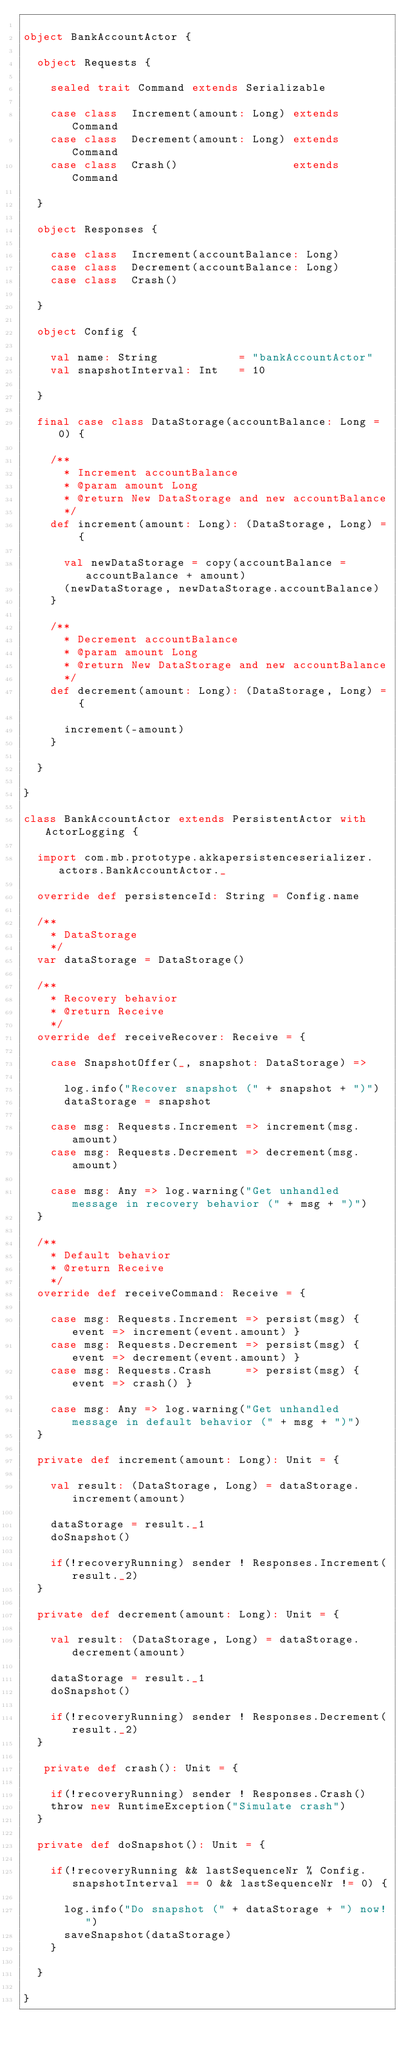<code> <loc_0><loc_0><loc_500><loc_500><_Scala_>
object BankAccountActor {

  object Requests {

    sealed trait Command extends Serializable

    case class  Increment(amount: Long) extends Command
    case class  Decrement(amount: Long) extends Command
    case class  Crash()                 extends Command

  }

  object Responses {

    case class  Increment(accountBalance: Long)
    case class  Decrement(accountBalance: Long)
    case class  Crash()

  }

  object Config {

    val name: String            = "bankAccountActor"
    val snapshotInterval: Int   = 10

  }

  final case class DataStorage(accountBalance: Long = 0) {

    /**
      * Increment accountBalance
      * @param amount Long
      * @return New DataStorage and new accountBalance
      */
    def increment(amount: Long): (DataStorage, Long) = {

      val newDataStorage = copy(accountBalance = accountBalance + amount)
      (newDataStorage, newDataStorage.accountBalance)
    }

    /**
      * Decrement accountBalance
      * @param amount Long
      * @return New DataStorage and new accountBalance
      */
    def decrement(amount: Long): (DataStorage, Long) = {

      increment(-amount)
    }

  }

}

class BankAccountActor extends PersistentActor with ActorLogging {

  import com.mb.prototype.akkapersistenceserializer.actors.BankAccountActor._

  override def persistenceId: String = Config.name

  /**
    * DataStorage
    */
  var dataStorage = DataStorage()

  /**
    * Recovery behavior
    * @return Receive
    */
  override def receiveRecover: Receive = {

    case SnapshotOffer(_, snapshot: DataStorage) =>

      log.info("Recover snapshot (" + snapshot + ")")
      dataStorage = snapshot

    case msg: Requests.Increment => increment(msg.amount)
    case msg: Requests.Decrement => decrement(msg.amount)

    case msg: Any => log.warning("Get unhandled message in recovery behavior (" + msg + ")")
  }

  /**
    * Default behavior
    * @return Receive
    */
  override def receiveCommand: Receive = {

    case msg: Requests.Increment => persist(msg) { event => increment(event.amount) }
    case msg: Requests.Decrement => persist(msg) { event => decrement(event.amount) }
    case msg: Requests.Crash     => persist(msg) { event => crash() }

    case msg: Any => log.warning("Get unhandled message in default behavior (" + msg + ")")
  }

  private def increment(amount: Long): Unit = {

    val result: (DataStorage, Long) = dataStorage.increment(amount)

    dataStorage = result._1
    doSnapshot()

    if(!recoveryRunning) sender ! Responses.Increment(result._2)
  }

  private def decrement(amount: Long): Unit = {

    val result: (DataStorage, Long) = dataStorage.decrement(amount)

    dataStorage = result._1
    doSnapshot()

    if(!recoveryRunning) sender ! Responses.Decrement(result._2)
  }

   private def crash(): Unit = {

    if(!recoveryRunning) sender ! Responses.Crash()
    throw new RuntimeException("Simulate crash")
  }

  private def doSnapshot(): Unit = {

    if(!recoveryRunning && lastSequenceNr % Config.snapshotInterval == 0 && lastSequenceNr != 0) {

      log.info("Do snapshot (" + dataStorage + ") now!")
      saveSnapshot(dataStorage)
    }

  }

}</code> 